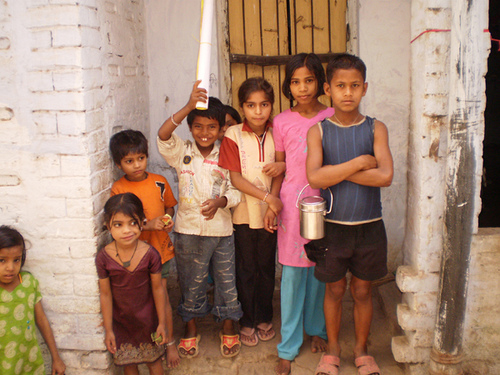<image>
Is there a small girl to the left of the tall boy? Yes. From this viewpoint, the small girl is positioned to the left side relative to the tall boy. Where is the small boy in relation to the tall girl? Is it to the right of the tall girl? Yes. From this viewpoint, the small boy is positioned to the right side relative to the tall girl. 